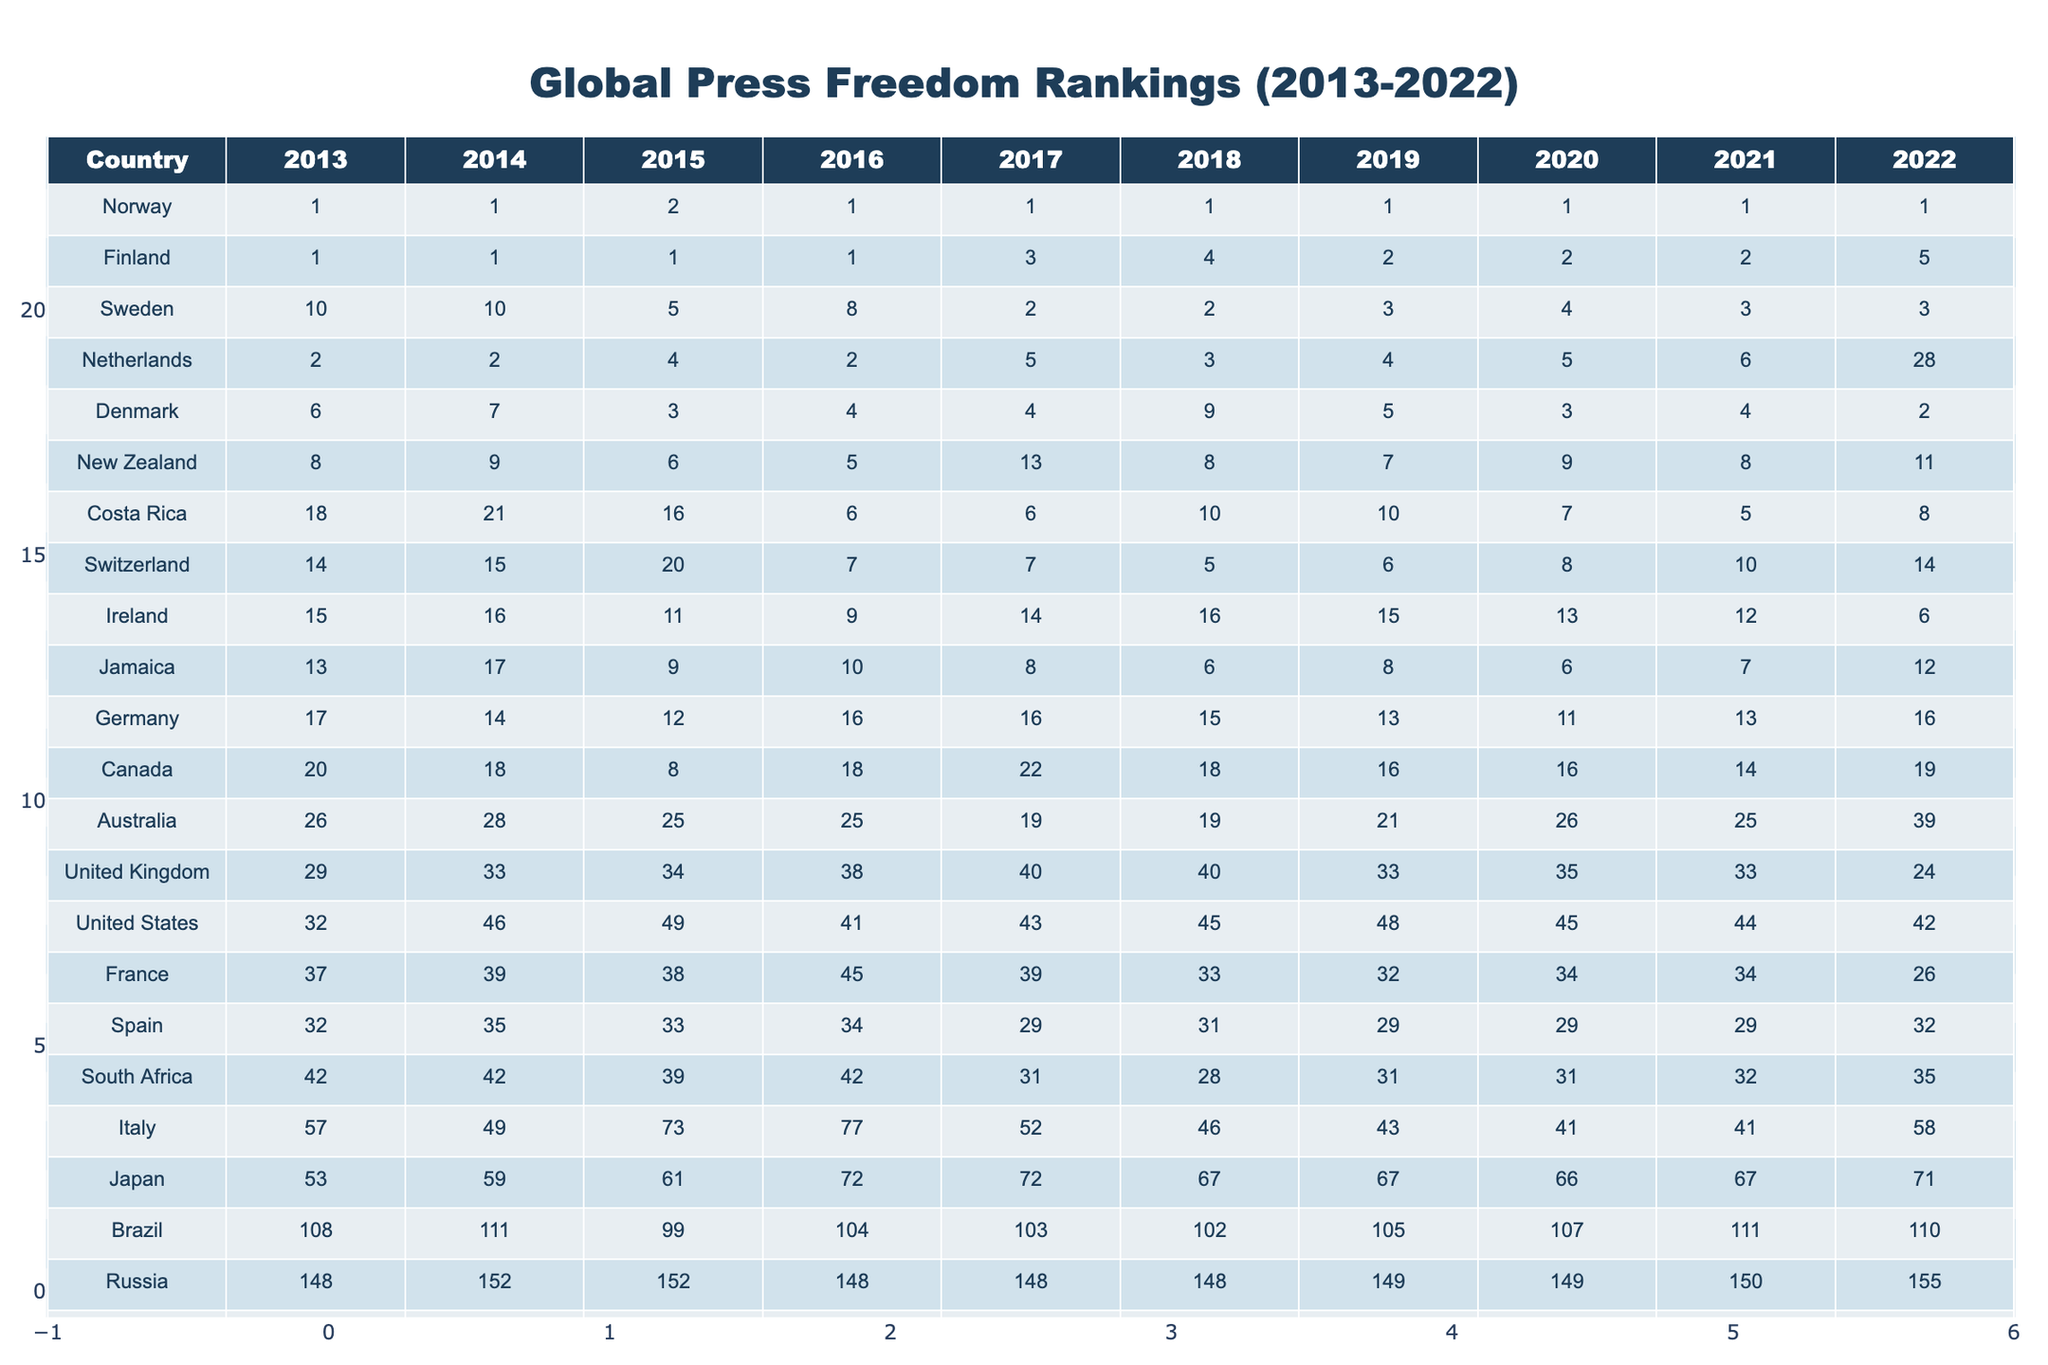What country ranked first in press freedom in 2013? Referring to the first column of the table for the year 2013, Norway is the only country that appears at rank 1, indicating it had the highest press freedom.
Answer: Norway Which country showed the most significant drop in ranking from 2013 to 2022? By comparing the ranks of each country from 2013 to 2022, Australia started at 26th place and fell to 39th, which is a drop of 13 places, the most significant decline observed.
Answer: Australia What is the average ranking of Finland from 2013 to 2022? To find the average ranking, sum the ranks of Finland between 2013 to 2022: (1 + 1 + 1 + 1 + 3 + 4 + 2 + 2 + 2 + 5) = 22. Then divide by 10, which results in an average of 2.2.
Answer: 2.2 Did North Korea ever rank better than 173 from 2013 to 2022? Examining North Korea's rankings for each year, the rank remained between 178 and 180 at all times, which indicates it never achieved a rank better than 173.
Answer: No Which country consistently ranked in the top 5 from 2013 to 2022, except for 2022? Looking at the ranking data, Finland consistently appeared in the top 5 for every year except in 2022, when it dropped to 5th place.
Answer: Finland What was the rank change for the United Kingdom from 2013 to 2022? The rank of the United Kingdom in 2013 was 29, and in 2022 it was 24. The change in rank can be calculated as 24 - 29 = -5, indicating an improvement by 5 places.
Answer: Improved by 5 places In which year did the Netherlands rank 28th? Checking the rankings of the Netherlands across all years, the value of 28 appears only in the year 2022.
Answer: 2022 Which country had the highest ranking in 2020? By looking at the rankings for 2020 across all countries, Norway holds the top position at rank 1, which is the highest ranking displayed.
Answer: Norway Compare the rankings of the United States in 2013 and 2022. What is the difference? The United States ranked 32nd in 2013 and dropped to 42nd in 2022. The difference can be calculated as 42 - 32 = 10, showing a decline of 10 places.
Answer: Declined by 10 places Did Canada improve its ranking from 2018 to 2022? In 2018, Canada was ranked 18th, and by 2022 it ranked 19th. This indicates that Canada's position worsened by 1 rank, showing no improvement.
Answer: No 